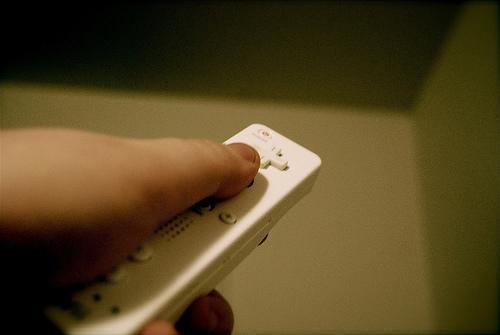How many remotes are there?
Give a very brief answer. 1. 